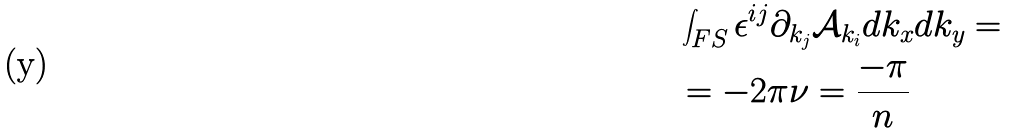Convert formula to latex. <formula><loc_0><loc_0><loc_500><loc_500>& \int _ { F S } \epsilon ^ { i j } \partial _ { k _ { j } } \mathcal { A } _ { k _ { i } } d k _ { x } d k _ { y } = \\ & = - 2 \pi \nu = \frac { - \pi } { n }</formula> 